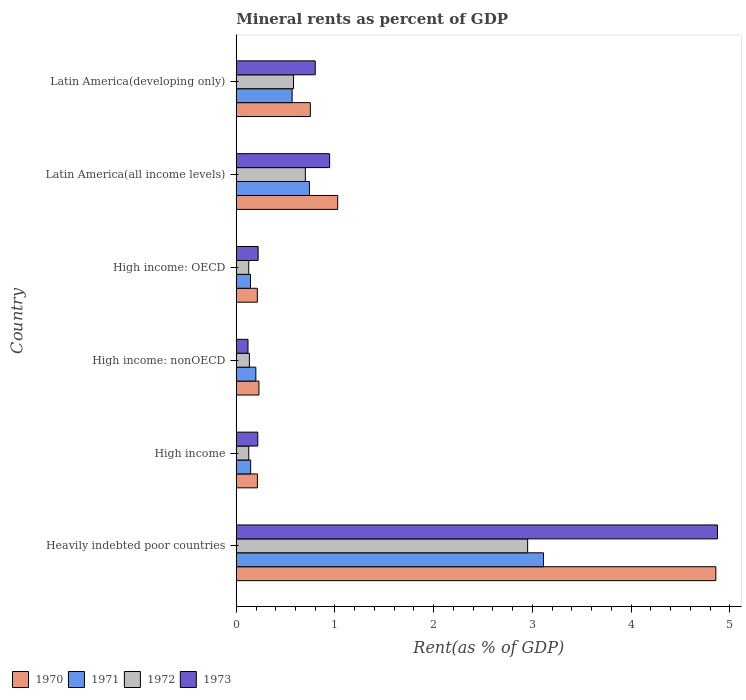How many different coloured bars are there?
Your response must be concise. 4. How many groups of bars are there?
Offer a very short reply. 6. Are the number of bars per tick equal to the number of legend labels?
Keep it short and to the point. Yes. What is the label of the 1st group of bars from the top?
Ensure brevity in your answer.  Latin America(developing only). In how many cases, is the number of bars for a given country not equal to the number of legend labels?
Offer a terse response. 0. What is the mineral rent in 1971 in High income: nonOECD?
Make the answer very short. 0.2. Across all countries, what is the maximum mineral rent in 1970?
Make the answer very short. 4.86. Across all countries, what is the minimum mineral rent in 1970?
Provide a succinct answer. 0.21. In which country was the mineral rent in 1972 maximum?
Your response must be concise. Heavily indebted poor countries. In which country was the mineral rent in 1972 minimum?
Keep it short and to the point. High income: OECD. What is the total mineral rent in 1971 in the graph?
Offer a very short reply. 4.91. What is the difference between the mineral rent in 1970 in High income and that in High income: nonOECD?
Provide a short and direct response. -0.02. What is the difference between the mineral rent in 1972 in Heavily indebted poor countries and the mineral rent in 1970 in High income?
Provide a succinct answer. 2.74. What is the average mineral rent in 1973 per country?
Keep it short and to the point. 1.2. What is the difference between the mineral rent in 1971 and mineral rent in 1973 in Latin America(developing only)?
Provide a succinct answer. -0.23. What is the ratio of the mineral rent in 1972 in Heavily indebted poor countries to that in High income?
Your answer should be compact. 23.3. Is the mineral rent in 1972 in High income less than that in Latin America(all income levels)?
Your response must be concise. Yes. Is the difference between the mineral rent in 1971 in High income and Latin America(developing only) greater than the difference between the mineral rent in 1973 in High income and Latin America(developing only)?
Give a very brief answer. Yes. What is the difference between the highest and the second highest mineral rent in 1972?
Provide a short and direct response. 2.25. What is the difference between the highest and the lowest mineral rent in 1970?
Ensure brevity in your answer.  4.64. In how many countries, is the mineral rent in 1970 greater than the average mineral rent in 1970 taken over all countries?
Provide a succinct answer. 1. Is the sum of the mineral rent in 1970 in Heavily indebted poor countries and Latin America(developing only) greater than the maximum mineral rent in 1973 across all countries?
Ensure brevity in your answer.  Yes. What does the 3rd bar from the top in Latin America(all income levels) represents?
Make the answer very short. 1971. What does the 1st bar from the bottom in High income: OECD represents?
Your answer should be very brief. 1970. How many bars are there?
Ensure brevity in your answer.  24. How many countries are there in the graph?
Provide a short and direct response. 6. What is the difference between two consecutive major ticks on the X-axis?
Your response must be concise. 1. Does the graph contain any zero values?
Ensure brevity in your answer.  No. Does the graph contain grids?
Ensure brevity in your answer.  No. How are the legend labels stacked?
Offer a very short reply. Horizontal. What is the title of the graph?
Give a very brief answer. Mineral rents as percent of GDP. Does "1960" appear as one of the legend labels in the graph?
Your answer should be very brief. No. What is the label or title of the X-axis?
Your answer should be compact. Rent(as % of GDP). What is the Rent(as % of GDP) in 1970 in Heavily indebted poor countries?
Your answer should be compact. 4.86. What is the Rent(as % of GDP) of 1971 in Heavily indebted poor countries?
Keep it short and to the point. 3.11. What is the Rent(as % of GDP) of 1972 in Heavily indebted poor countries?
Provide a succinct answer. 2.95. What is the Rent(as % of GDP) of 1973 in Heavily indebted poor countries?
Provide a short and direct response. 4.87. What is the Rent(as % of GDP) in 1970 in High income?
Keep it short and to the point. 0.21. What is the Rent(as % of GDP) of 1971 in High income?
Offer a very short reply. 0.15. What is the Rent(as % of GDP) of 1972 in High income?
Give a very brief answer. 0.13. What is the Rent(as % of GDP) in 1973 in High income?
Offer a very short reply. 0.22. What is the Rent(as % of GDP) in 1970 in High income: nonOECD?
Your response must be concise. 0.23. What is the Rent(as % of GDP) of 1971 in High income: nonOECD?
Give a very brief answer. 0.2. What is the Rent(as % of GDP) of 1972 in High income: nonOECD?
Keep it short and to the point. 0.13. What is the Rent(as % of GDP) in 1973 in High income: nonOECD?
Your response must be concise. 0.12. What is the Rent(as % of GDP) of 1970 in High income: OECD?
Ensure brevity in your answer.  0.21. What is the Rent(as % of GDP) in 1971 in High income: OECD?
Offer a very short reply. 0.14. What is the Rent(as % of GDP) of 1972 in High income: OECD?
Provide a short and direct response. 0.13. What is the Rent(as % of GDP) in 1973 in High income: OECD?
Ensure brevity in your answer.  0.22. What is the Rent(as % of GDP) in 1970 in Latin America(all income levels)?
Give a very brief answer. 1.03. What is the Rent(as % of GDP) of 1971 in Latin America(all income levels)?
Ensure brevity in your answer.  0.74. What is the Rent(as % of GDP) in 1972 in Latin America(all income levels)?
Provide a succinct answer. 0.7. What is the Rent(as % of GDP) in 1973 in Latin America(all income levels)?
Your answer should be compact. 0.95. What is the Rent(as % of GDP) of 1970 in Latin America(developing only)?
Ensure brevity in your answer.  0.75. What is the Rent(as % of GDP) in 1971 in Latin America(developing only)?
Offer a terse response. 0.57. What is the Rent(as % of GDP) of 1972 in Latin America(developing only)?
Provide a succinct answer. 0.58. What is the Rent(as % of GDP) in 1973 in Latin America(developing only)?
Offer a terse response. 0.8. Across all countries, what is the maximum Rent(as % of GDP) in 1970?
Offer a very short reply. 4.86. Across all countries, what is the maximum Rent(as % of GDP) of 1971?
Keep it short and to the point. 3.11. Across all countries, what is the maximum Rent(as % of GDP) in 1972?
Your response must be concise. 2.95. Across all countries, what is the maximum Rent(as % of GDP) in 1973?
Ensure brevity in your answer.  4.87. Across all countries, what is the minimum Rent(as % of GDP) of 1970?
Offer a very short reply. 0.21. Across all countries, what is the minimum Rent(as % of GDP) of 1971?
Provide a short and direct response. 0.14. Across all countries, what is the minimum Rent(as % of GDP) in 1972?
Give a very brief answer. 0.13. Across all countries, what is the minimum Rent(as % of GDP) in 1973?
Your answer should be very brief. 0.12. What is the total Rent(as % of GDP) in 1970 in the graph?
Your response must be concise. 7.29. What is the total Rent(as % of GDP) of 1971 in the graph?
Provide a short and direct response. 4.91. What is the total Rent(as % of GDP) of 1972 in the graph?
Your answer should be compact. 4.62. What is the total Rent(as % of GDP) of 1973 in the graph?
Provide a short and direct response. 7.18. What is the difference between the Rent(as % of GDP) in 1970 in Heavily indebted poor countries and that in High income?
Keep it short and to the point. 4.64. What is the difference between the Rent(as % of GDP) of 1971 in Heavily indebted poor countries and that in High income?
Ensure brevity in your answer.  2.97. What is the difference between the Rent(as % of GDP) in 1972 in Heavily indebted poor countries and that in High income?
Keep it short and to the point. 2.82. What is the difference between the Rent(as % of GDP) of 1973 in Heavily indebted poor countries and that in High income?
Provide a succinct answer. 4.66. What is the difference between the Rent(as % of GDP) in 1970 in Heavily indebted poor countries and that in High income: nonOECD?
Your response must be concise. 4.63. What is the difference between the Rent(as % of GDP) in 1971 in Heavily indebted poor countries and that in High income: nonOECD?
Provide a succinct answer. 2.91. What is the difference between the Rent(as % of GDP) in 1972 in Heavily indebted poor countries and that in High income: nonOECD?
Your response must be concise. 2.82. What is the difference between the Rent(as % of GDP) in 1973 in Heavily indebted poor countries and that in High income: nonOECD?
Offer a very short reply. 4.75. What is the difference between the Rent(as % of GDP) in 1970 in Heavily indebted poor countries and that in High income: OECD?
Your answer should be very brief. 4.64. What is the difference between the Rent(as % of GDP) in 1971 in Heavily indebted poor countries and that in High income: OECD?
Your answer should be compact. 2.97. What is the difference between the Rent(as % of GDP) in 1972 in Heavily indebted poor countries and that in High income: OECD?
Give a very brief answer. 2.83. What is the difference between the Rent(as % of GDP) in 1973 in Heavily indebted poor countries and that in High income: OECD?
Your answer should be compact. 4.65. What is the difference between the Rent(as % of GDP) in 1970 in Heavily indebted poor countries and that in Latin America(all income levels)?
Your response must be concise. 3.83. What is the difference between the Rent(as % of GDP) in 1971 in Heavily indebted poor countries and that in Latin America(all income levels)?
Your response must be concise. 2.37. What is the difference between the Rent(as % of GDP) of 1972 in Heavily indebted poor countries and that in Latin America(all income levels)?
Your response must be concise. 2.25. What is the difference between the Rent(as % of GDP) of 1973 in Heavily indebted poor countries and that in Latin America(all income levels)?
Provide a short and direct response. 3.93. What is the difference between the Rent(as % of GDP) in 1970 in Heavily indebted poor countries and that in Latin America(developing only)?
Ensure brevity in your answer.  4.11. What is the difference between the Rent(as % of GDP) of 1971 in Heavily indebted poor countries and that in Latin America(developing only)?
Your answer should be very brief. 2.55. What is the difference between the Rent(as % of GDP) in 1972 in Heavily indebted poor countries and that in Latin America(developing only)?
Ensure brevity in your answer.  2.37. What is the difference between the Rent(as % of GDP) in 1973 in Heavily indebted poor countries and that in Latin America(developing only)?
Offer a very short reply. 4.07. What is the difference between the Rent(as % of GDP) in 1970 in High income and that in High income: nonOECD?
Ensure brevity in your answer.  -0.02. What is the difference between the Rent(as % of GDP) of 1971 in High income and that in High income: nonOECD?
Make the answer very short. -0.05. What is the difference between the Rent(as % of GDP) in 1972 in High income and that in High income: nonOECD?
Ensure brevity in your answer.  -0.01. What is the difference between the Rent(as % of GDP) in 1973 in High income and that in High income: nonOECD?
Make the answer very short. 0.1. What is the difference between the Rent(as % of GDP) of 1970 in High income and that in High income: OECD?
Your answer should be compact. 0. What is the difference between the Rent(as % of GDP) of 1971 in High income and that in High income: OECD?
Give a very brief answer. 0. What is the difference between the Rent(as % of GDP) of 1972 in High income and that in High income: OECD?
Your answer should be compact. 0. What is the difference between the Rent(as % of GDP) of 1973 in High income and that in High income: OECD?
Ensure brevity in your answer.  -0. What is the difference between the Rent(as % of GDP) of 1970 in High income and that in Latin America(all income levels)?
Your answer should be compact. -0.81. What is the difference between the Rent(as % of GDP) of 1971 in High income and that in Latin America(all income levels)?
Your answer should be very brief. -0.6. What is the difference between the Rent(as % of GDP) of 1972 in High income and that in Latin America(all income levels)?
Your response must be concise. -0.57. What is the difference between the Rent(as % of GDP) of 1973 in High income and that in Latin America(all income levels)?
Make the answer very short. -0.73. What is the difference between the Rent(as % of GDP) of 1970 in High income and that in Latin America(developing only)?
Keep it short and to the point. -0.54. What is the difference between the Rent(as % of GDP) in 1971 in High income and that in Latin America(developing only)?
Provide a short and direct response. -0.42. What is the difference between the Rent(as % of GDP) of 1972 in High income and that in Latin America(developing only)?
Your response must be concise. -0.45. What is the difference between the Rent(as % of GDP) of 1973 in High income and that in Latin America(developing only)?
Offer a terse response. -0.58. What is the difference between the Rent(as % of GDP) in 1970 in High income: nonOECD and that in High income: OECD?
Your answer should be compact. 0.02. What is the difference between the Rent(as % of GDP) of 1971 in High income: nonOECD and that in High income: OECD?
Give a very brief answer. 0.05. What is the difference between the Rent(as % of GDP) of 1972 in High income: nonOECD and that in High income: OECD?
Your response must be concise. 0.01. What is the difference between the Rent(as % of GDP) in 1973 in High income: nonOECD and that in High income: OECD?
Offer a very short reply. -0.1. What is the difference between the Rent(as % of GDP) in 1970 in High income: nonOECD and that in Latin America(all income levels)?
Your answer should be compact. -0.8. What is the difference between the Rent(as % of GDP) in 1971 in High income: nonOECD and that in Latin America(all income levels)?
Your answer should be compact. -0.54. What is the difference between the Rent(as % of GDP) of 1972 in High income: nonOECD and that in Latin America(all income levels)?
Keep it short and to the point. -0.57. What is the difference between the Rent(as % of GDP) in 1973 in High income: nonOECD and that in Latin America(all income levels)?
Make the answer very short. -0.83. What is the difference between the Rent(as % of GDP) in 1970 in High income: nonOECD and that in Latin America(developing only)?
Ensure brevity in your answer.  -0.52. What is the difference between the Rent(as % of GDP) in 1971 in High income: nonOECD and that in Latin America(developing only)?
Provide a succinct answer. -0.37. What is the difference between the Rent(as % of GDP) of 1972 in High income: nonOECD and that in Latin America(developing only)?
Offer a terse response. -0.45. What is the difference between the Rent(as % of GDP) of 1973 in High income: nonOECD and that in Latin America(developing only)?
Your answer should be compact. -0.68. What is the difference between the Rent(as % of GDP) of 1970 in High income: OECD and that in Latin America(all income levels)?
Keep it short and to the point. -0.81. What is the difference between the Rent(as % of GDP) in 1971 in High income: OECD and that in Latin America(all income levels)?
Your answer should be compact. -0.6. What is the difference between the Rent(as % of GDP) in 1972 in High income: OECD and that in Latin America(all income levels)?
Keep it short and to the point. -0.57. What is the difference between the Rent(as % of GDP) in 1973 in High income: OECD and that in Latin America(all income levels)?
Your answer should be very brief. -0.72. What is the difference between the Rent(as % of GDP) in 1970 in High income: OECD and that in Latin America(developing only)?
Your response must be concise. -0.54. What is the difference between the Rent(as % of GDP) of 1971 in High income: OECD and that in Latin America(developing only)?
Your answer should be very brief. -0.42. What is the difference between the Rent(as % of GDP) of 1972 in High income: OECD and that in Latin America(developing only)?
Provide a succinct answer. -0.45. What is the difference between the Rent(as % of GDP) of 1973 in High income: OECD and that in Latin America(developing only)?
Offer a terse response. -0.58. What is the difference between the Rent(as % of GDP) in 1970 in Latin America(all income levels) and that in Latin America(developing only)?
Ensure brevity in your answer.  0.28. What is the difference between the Rent(as % of GDP) of 1971 in Latin America(all income levels) and that in Latin America(developing only)?
Offer a very short reply. 0.18. What is the difference between the Rent(as % of GDP) in 1972 in Latin America(all income levels) and that in Latin America(developing only)?
Keep it short and to the point. 0.12. What is the difference between the Rent(as % of GDP) in 1973 in Latin America(all income levels) and that in Latin America(developing only)?
Provide a succinct answer. 0.15. What is the difference between the Rent(as % of GDP) in 1970 in Heavily indebted poor countries and the Rent(as % of GDP) in 1971 in High income?
Provide a succinct answer. 4.71. What is the difference between the Rent(as % of GDP) in 1970 in Heavily indebted poor countries and the Rent(as % of GDP) in 1972 in High income?
Your answer should be compact. 4.73. What is the difference between the Rent(as % of GDP) in 1970 in Heavily indebted poor countries and the Rent(as % of GDP) in 1973 in High income?
Ensure brevity in your answer.  4.64. What is the difference between the Rent(as % of GDP) of 1971 in Heavily indebted poor countries and the Rent(as % of GDP) of 1972 in High income?
Your response must be concise. 2.99. What is the difference between the Rent(as % of GDP) in 1971 in Heavily indebted poor countries and the Rent(as % of GDP) in 1973 in High income?
Your answer should be compact. 2.89. What is the difference between the Rent(as % of GDP) of 1972 in Heavily indebted poor countries and the Rent(as % of GDP) of 1973 in High income?
Provide a succinct answer. 2.73. What is the difference between the Rent(as % of GDP) of 1970 in Heavily indebted poor countries and the Rent(as % of GDP) of 1971 in High income: nonOECD?
Provide a succinct answer. 4.66. What is the difference between the Rent(as % of GDP) of 1970 in Heavily indebted poor countries and the Rent(as % of GDP) of 1972 in High income: nonOECD?
Offer a very short reply. 4.72. What is the difference between the Rent(as % of GDP) in 1970 in Heavily indebted poor countries and the Rent(as % of GDP) in 1973 in High income: nonOECD?
Ensure brevity in your answer.  4.74. What is the difference between the Rent(as % of GDP) of 1971 in Heavily indebted poor countries and the Rent(as % of GDP) of 1972 in High income: nonOECD?
Ensure brevity in your answer.  2.98. What is the difference between the Rent(as % of GDP) of 1971 in Heavily indebted poor countries and the Rent(as % of GDP) of 1973 in High income: nonOECD?
Ensure brevity in your answer.  2.99. What is the difference between the Rent(as % of GDP) in 1972 in Heavily indebted poor countries and the Rent(as % of GDP) in 1973 in High income: nonOECD?
Your answer should be compact. 2.83. What is the difference between the Rent(as % of GDP) of 1970 in Heavily indebted poor countries and the Rent(as % of GDP) of 1971 in High income: OECD?
Give a very brief answer. 4.71. What is the difference between the Rent(as % of GDP) of 1970 in Heavily indebted poor countries and the Rent(as % of GDP) of 1972 in High income: OECD?
Keep it short and to the point. 4.73. What is the difference between the Rent(as % of GDP) of 1970 in Heavily indebted poor countries and the Rent(as % of GDP) of 1973 in High income: OECD?
Your answer should be very brief. 4.64. What is the difference between the Rent(as % of GDP) in 1971 in Heavily indebted poor countries and the Rent(as % of GDP) in 1972 in High income: OECD?
Make the answer very short. 2.99. What is the difference between the Rent(as % of GDP) of 1971 in Heavily indebted poor countries and the Rent(as % of GDP) of 1973 in High income: OECD?
Ensure brevity in your answer.  2.89. What is the difference between the Rent(as % of GDP) in 1972 in Heavily indebted poor countries and the Rent(as % of GDP) in 1973 in High income: OECD?
Your answer should be compact. 2.73. What is the difference between the Rent(as % of GDP) in 1970 in Heavily indebted poor countries and the Rent(as % of GDP) in 1971 in Latin America(all income levels)?
Your response must be concise. 4.12. What is the difference between the Rent(as % of GDP) of 1970 in Heavily indebted poor countries and the Rent(as % of GDP) of 1972 in Latin America(all income levels)?
Provide a succinct answer. 4.16. What is the difference between the Rent(as % of GDP) of 1970 in Heavily indebted poor countries and the Rent(as % of GDP) of 1973 in Latin America(all income levels)?
Provide a succinct answer. 3.91. What is the difference between the Rent(as % of GDP) of 1971 in Heavily indebted poor countries and the Rent(as % of GDP) of 1972 in Latin America(all income levels)?
Offer a very short reply. 2.41. What is the difference between the Rent(as % of GDP) of 1971 in Heavily indebted poor countries and the Rent(as % of GDP) of 1973 in Latin America(all income levels)?
Provide a short and direct response. 2.17. What is the difference between the Rent(as % of GDP) of 1972 in Heavily indebted poor countries and the Rent(as % of GDP) of 1973 in Latin America(all income levels)?
Offer a terse response. 2.01. What is the difference between the Rent(as % of GDP) of 1970 in Heavily indebted poor countries and the Rent(as % of GDP) of 1971 in Latin America(developing only)?
Your response must be concise. 4.29. What is the difference between the Rent(as % of GDP) in 1970 in Heavily indebted poor countries and the Rent(as % of GDP) in 1972 in Latin America(developing only)?
Keep it short and to the point. 4.28. What is the difference between the Rent(as % of GDP) of 1970 in Heavily indebted poor countries and the Rent(as % of GDP) of 1973 in Latin America(developing only)?
Offer a terse response. 4.06. What is the difference between the Rent(as % of GDP) in 1971 in Heavily indebted poor countries and the Rent(as % of GDP) in 1972 in Latin America(developing only)?
Offer a very short reply. 2.53. What is the difference between the Rent(as % of GDP) in 1971 in Heavily indebted poor countries and the Rent(as % of GDP) in 1973 in Latin America(developing only)?
Keep it short and to the point. 2.31. What is the difference between the Rent(as % of GDP) in 1972 in Heavily indebted poor countries and the Rent(as % of GDP) in 1973 in Latin America(developing only)?
Keep it short and to the point. 2.15. What is the difference between the Rent(as % of GDP) of 1970 in High income and the Rent(as % of GDP) of 1971 in High income: nonOECD?
Your response must be concise. 0.02. What is the difference between the Rent(as % of GDP) in 1970 in High income and the Rent(as % of GDP) in 1972 in High income: nonOECD?
Your answer should be compact. 0.08. What is the difference between the Rent(as % of GDP) of 1970 in High income and the Rent(as % of GDP) of 1973 in High income: nonOECD?
Your response must be concise. 0.1. What is the difference between the Rent(as % of GDP) in 1971 in High income and the Rent(as % of GDP) in 1972 in High income: nonOECD?
Ensure brevity in your answer.  0.01. What is the difference between the Rent(as % of GDP) in 1971 in High income and the Rent(as % of GDP) in 1973 in High income: nonOECD?
Give a very brief answer. 0.03. What is the difference between the Rent(as % of GDP) of 1972 in High income and the Rent(as % of GDP) of 1973 in High income: nonOECD?
Your answer should be compact. 0.01. What is the difference between the Rent(as % of GDP) in 1970 in High income and the Rent(as % of GDP) in 1971 in High income: OECD?
Your answer should be compact. 0.07. What is the difference between the Rent(as % of GDP) in 1970 in High income and the Rent(as % of GDP) in 1972 in High income: OECD?
Your response must be concise. 0.09. What is the difference between the Rent(as % of GDP) of 1970 in High income and the Rent(as % of GDP) of 1973 in High income: OECD?
Offer a very short reply. -0.01. What is the difference between the Rent(as % of GDP) in 1971 in High income and the Rent(as % of GDP) in 1972 in High income: OECD?
Ensure brevity in your answer.  0.02. What is the difference between the Rent(as % of GDP) in 1971 in High income and the Rent(as % of GDP) in 1973 in High income: OECD?
Provide a short and direct response. -0.08. What is the difference between the Rent(as % of GDP) of 1972 in High income and the Rent(as % of GDP) of 1973 in High income: OECD?
Your response must be concise. -0.1. What is the difference between the Rent(as % of GDP) of 1970 in High income and the Rent(as % of GDP) of 1971 in Latin America(all income levels)?
Provide a succinct answer. -0.53. What is the difference between the Rent(as % of GDP) in 1970 in High income and the Rent(as % of GDP) in 1972 in Latin America(all income levels)?
Keep it short and to the point. -0.49. What is the difference between the Rent(as % of GDP) in 1970 in High income and the Rent(as % of GDP) in 1973 in Latin America(all income levels)?
Keep it short and to the point. -0.73. What is the difference between the Rent(as % of GDP) in 1971 in High income and the Rent(as % of GDP) in 1972 in Latin America(all income levels)?
Keep it short and to the point. -0.55. What is the difference between the Rent(as % of GDP) of 1971 in High income and the Rent(as % of GDP) of 1973 in Latin America(all income levels)?
Provide a short and direct response. -0.8. What is the difference between the Rent(as % of GDP) of 1972 in High income and the Rent(as % of GDP) of 1973 in Latin America(all income levels)?
Keep it short and to the point. -0.82. What is the difference between the Rent(as % of GDP) of 1970 in High income and the Rent(as % of GDP) of 1971 in Latin America(developing only)?
Make the answer very short. -0.35. What is the difference between the Rent(as % of GDP) of 1970 in High income and the Rent(as % of GDP) of 1972 in Latin America(developing only)?
Provide a succinct answer. -0.37. What is the difference between the Rent(as % of GDP) of 1970 in High income and the Rent(as % of GDP) of 1973 in Latin America(developing only)?
Offer a terse response. -0.59. What is the difference between the Rent(as % of GDP) in 1971 in High income and the Rent(as % of GDP) in 1972 in Latin America(developing only)?
Your response must be concise. -0.43. What is the difference between the Rent(as % of GDP) of 1971 in High income and the Rent(as % of GDP) of 1973 in Latin America(developing only)?
Give a very brief answer. -0.65. What is the difference between the Rent(as % of GDP) of 1972 in High income and the Rent(as % of GDP) of 1973 in Latin America(developing only)?
Your answer should be very brief. -0.67. What is the difference between the Rent(as % of GDP) in 1970 in High income: nonOECD and the Rent(as % of GDP) in 1971 in High income: OECD?
Provide a short and direct response. 0.09. What is the difference between the Rent(as % of GDP) in 1970 in High income: nonOECD and the Rent(as % of GDP) in 1972 in High income: OECD?
Make the answer very short. 0.1. What is the difference between the Rent(as % of GDP) in 1970 in High income: nonOECD and the Rent(as % of GDP) in 1973 in High income: OECD?
Make the answer very short. 0.01. What is the difference between the Rent(as % of GDP) in 1971 in High income: nonOECD and the Rent(as % of GDP) in 1972 in High income: OECD?
Provide a succinct answer. 0.07. What is the difference between the Rent(as % of GDP) of 1971 in High income: nonOECD and the Rent(as % of GDP) of 1973 in High income: OECD?
Provide a short and direct response. -0.02. What is the difference between the Rent(as % of GDP) in 1972 in High income: nonOECD and the Rent(as % of GDP) in 1973 in High income: OECD?
Give a very brief answer. -0.09. What is the difference between the Rent(as % of GDP) of 1970 in High income: nonOECD and the Rent(as % of GDP) of 1971 in Latin America(all income levels)?
Your answer should be very brief. -0.51. What is the difference between the Rent(as % of GDP) in 1970 in High income: nonOECD and the Rent(as % of GDP) in 1972 in Latin America(all income levels)?
Provide a short and direct response. -0.47. What is the difference between the Rent(as % of GDP) in 1970 in High income: nonOECD and the Rent(as % of GDP) in 1973 in Latin America(all income levels)?
Provide a succinct answer. -0.72. What is the difference between the Rent(as % of GDP) of 1971 in High income: nonOECD and the Rent(as % of GDP) of 1972 in Latin America(all income levels)?
Make the answer very short. -0.5. What is the difference between the Rent(as % of GDP) of 1971 in High income: nonOECD and the Rent(as % of GDP) of 1973 in Latin America(all income levels)?
Make the answer very short. -0.75. What is the difference between the Rent(as % of GDP) of 1972 in High income: nonOECD and the Rent(as % of GDP) of 1973 in Latin America(all income levels)?
Give a very brief answer. -0.81. What is the difference between the Rent(as % of GDP) in 1970 in High income: nonOECD and the Rent(as % of GDP) in 1971 in Latin America(developing only)?
Offer a very short reply. -0.34. What is the difference between the Rent(as % of GDP) in 1970 in High income: nonOECD and the Rent(as % of GDP) in 1972 in Latin America(developing only)?
Give a very brief answer. -0.35. What is the difference between the Rent(as % of GDP) in 1970 in High income: nonOECD and the Rent(as % of GDP) in 1973 in Latin America(developing only)?
Keep it short and to the point. -0.57. What is the difference between the Rent(as % of GDP) of 1971 in High income: nonOECD and the Rent(as % of GDP) of 1972 in Latin America(developing only)?
Ensure brevity in your answer.  -0.38. What is the difference between the Rent(as % of GDP) of 1971 in High income: nonOECD and the Rent(as % of GDP) of 1973 in Latin America(developing only)?
Offer a very short reply. -0.6. What is the difference between the Rent(as % of GDP) of 1972 in High income: nonOECD and the Rent(as % of GDP) of 1973 in Latin America(developing only)?
Give a very brief answer. -0.67. What is the difference between the Rent(as % of GDP) in 1970 in High income: OECD and the Rent(as % of GDP) in 1971 in Latin America(all income levels)?
Give a very brief answer. -0.53. What is the difference between the Rent(as % of GDP) of 1970 in High income: OECD and the Rent(as % of GDP) of 1972 in Latin America(all income levels)?
Your response must be concise. -0.49. What is the difference between the Rent(as % of GDP) of 1970 in High income: OECD and the Rent(as % of GDP) of 1973 in Latin America(all income levels)?
Your answer should be very brief. -0.73. What is the difference between the Rent(as % of GDP) of 1971 in High income: OECD and the Rent(as % of GDP) of 1972 in Latin America(all income levels)?
Provide a short and direct response. -0.56. What is the difference between the Rent(as % of GDP) of 1971 in High income: OECD and the Rent(as % of GDP) of 1973 in Latin America(all income levels)?
Offer a terse response. -0.8. What is the difference between the Rent(as % of GDP) in 1972 in High income: OECD and the Rent(as % of GDP) in 1973 in Latin America(all income levels)?
Provide a succinct answer. -0.82. What is the difference between the Rent(as % of GDP) in 1970 in High income: OECD and the Rent(as % of GDP) in 1971 in Latin America(developing only)?
Provide a short and direct response. -0.35. What is the difference between the Rent(as % of GDP) in 1970 in High income: OECD and the Rent(as % of GDP) in 1972 in Latin America(developing only)?
Ensure brevity in your answer.  -0.37. What is the difference between the Rent(as % of GDP) of 1970 in High income: OECD and the Rent(as % of GDP) of 1973 in Latin America(developing only)?
Ensure brevity in your answer.  -0.59. What is the difference between the Rent(as % of GDP) of 1971 in High income: OECD and the Rent(as % of GDP) of 1972 in Latin America(developing only)?
Provide a short and direct response. -0.44. What is the difference between the Rent(as % of GDP) of 1971 in High income: OECD and the Rent(as % of GDP) of 1973 in Latin America(developing only)?
Ensure brevity in your answer.  -0.66. What is the difference between the Rent(as % of GDP) in 1972 in High income: OECD and the Rent(as % of GDP) in 1973 in Latin America(developing only)?
Your response must be concise. -0.67. What is the difference between the Rent(as % of GDP) in 1970 in Latin America(all income levels) and the Rent(as % of GDP) in 1971 in Latin America(developing only)?
Give a very brief answer. 0.46. What is the difference between the Rent(as % of GDP) of 1970 in Latin America(all income levels) and the Rent(as % of GDP) of 1972 in Latin America(developing only)?
Provide a short and direct response. 0.45. What is the difference between the Rent(as % of GDP) in 1970 in Latin America(all income levels) and the Rent(as % of GDP) in 1973 in Latin America(developing only)?
Provide a succinct answer. 0.23. What is the difference between the Rent(as % of GDP) in 1971 in Latin America(all income levels) and the Rent(as % of GDP) in 1972 in Latin America(developing only)?
Offer a terse response. 0.16. What is the difference between the Rent(as % of GDP) in 1971 in Latin America(all income levels) and the Rent(as % of GDP) in 1973 in Latin America(developing only)?
Provide a succinct answer. -0.06. What is the difference between the Rent(as % of GDP) of 1972 in Latin America(all income levels) and the Rent(as % of GDP) of 1973 in Latin America(developing only)?
Give a very brief answer. -0.1. What is the average Rent(as % of GDP) in 1970 per country?
Provide a short and direct response. 1.22. What is the average Rent(as % of GDP) of 1971 per country?
Offer a terse response. 0.82. What is the average Rent(as % of GDP) in 1972 per country?
Make the answer very short. 0.77. What is the average Rent(as % of GDP) in 1973 per country?
Ensure brevity in your answer.  1.2. What is the difference between the Rent(as % of GDP) in 1970 and Rent(as % of GDP) in 1971 in Heavily indebted poor countries?
Keep it short and to the point. 1.75. What is the difference between the Rent(as % of GDP) of 1970 and Rent(as % of GDP) of 1972 in Heavily indebted poor countries?
Ensure brevity in your answer.  1.91. What is the difference between the Rent(as % of GDP) of 1970 and Rent(as % of GDP) of 1973 in Heavily indebted poor countries?
Your answer should be compact. -0.02. What is the difference between the Rent(as % of GDP) in 1971 and Rent(as % of GDP) in 1972 in Heavily indebted poor countries?
Offer a terse response. 0.16. What is the difference between the Rent(as % of GDP) of 1971 and Rent(as % of GDP) of 1973 in Heavily indebted poor countries?
Ensure brevity in your answer.  -1.76. What is the difference between the Rent(as % of GDP) of 1972 and Rent(as % of GDP) of 1973 in Heavily indebted poor countries?
Your answer should be compact. -1.92. What is the difference between the Rent(as % of GDP) in 1970 and Rent(as % of GDP) in 1971 in High income?
Make the answer very short. 0.07. What is the difference between the Rent(as % of GDP) in 1970 and Rent(as % of GDP) in 1972 in High income?
Provide a succinct answer. 0.09. What is the difference between the Rent(as % of GDP) in 1970 and Rent(as % of GDP) in 1973 in High income?
Offer a terse response. -0. What is the difference between the Rent(as % of GDP) of 1971 and Rent(as % of GDP) of 1972 in High income?
Your answer should be compact. 0.02. What is the difference between the Rent(as % of GDP) of 1971 and Rent(as % of GDP) of 1973 in High income?
Your answer should be compact. -0.07. What is the difference between the Rent(as % of GDP) of 1972 and Rent(as % of GDP) of 1973 in High income?
Provide a succinct answer. -0.09. What is the difference between the Rent(as % of GDP) in 1970 and Rent(as % of GDP) in 1971 in High income: nonOECD?
Your response must be concise. 0.03. What is the difference between the Rent(as % of GDP) of 1970 and Rent(as % of GDP) of 1972 in High income: nonOECD?
Your answer should be very brief. 0.1. What is the difference between the Rent(as % of GDP) of 1970 and Rent(as % of GDP) of 1973 in High income: nonOECD?
Provide a short and direct response. 0.11. What is the difference between the Rent(as % of GDP) in 1971 and Rent(as % of GDP) in 1972 in High income: nonOECD?
Provide a succinct answer. 0.07. What is the difference between the Rent(as % of GDP) of 1971 and Rent(as % of GDP) of 1973 in High income: nonOECD?
Offer a terse response. 0.08. What is the difference between the Rent(as % of GDP) of 1972 and Rent(as % of GDP) of 1973 in High income: nonOECD?
Your answer should be compact. 0.01. What is the difference between the Rent(as % of GDP) of 1970 and Rent(as % of GDP) of 1971 in High income: OECD?
Keep it short and to the point. 0.07. What is the difference between the Rent(as % of GDP) of 1970 and Rent(as % of GDP) of 1972 in High income: OECD?
Make the answer very short. 0.09. What is the difference between the Rent(as % of GDP) of 1970 and Rent(as % of GDP) of 1973 in High income: OECD?
Offer a very short reply. -0.01. What is the difference between the Rent(as % of GDP) of 1971 and Rent(as % of GDP) of 1972 in High income: OECD?
Provide a short and direct response. 0.02. What is the difference between the Rent(as % of GDP) in 1971 and Rent(as % of GDP) in 1973 in High income: OECD?
Offer a terse response. -0.08. What is the difference between the Rent(as % of GDP) in 1972 and Rent(as % of GDP) in 1973 in High income: OECD?
Provide a short and direct response. -0.1. What is the difference between the Rent(as % of GDP) of 1970 and Rent(as % of GDP) of 1971 in Latin America(all income levels)?
Give a very brief answer. 0.29. What is the difference between the Rent(as % of GDP) in 1970 and Rent(as % of GDP) in 1972 in Latin America(all income levels)?
Your answer should be very brief. 0.33. What is the difference between the Rent(as % of GDP) in 1970 and Rent(as % of GDP) in 1973 in Latin America(all income levels)?
Keep it short and to the point. 0.08. What is the difference between the Rent(as % of GDP) of 1971 and Rent(as % of GDP) of 1972 in Latin America(all income levels)?
Provide a succinct answer. 0.04. What is the difference between the Rent(as % of GDP) in 1971 and Rent(as % of GDP) in 1973 in Latin America(all income levels)?
Your response must be concise. -0.2. What is the difference between the Rent(as % of GDP) of 1972 and Rent(as % of GDP) of 1973 in Latin America(all income levels)?
Offer a terse response. -0.25. What is the difference between the Rent(as % of GDP) of 1970 and Rent(as % of GDP) of 1971 in Latin America(developing only)?
Offer a terse response. 0.18. What is the difference between the Rent(as % of GDP) of 1970 and Rent(as % of GDP) of 1972 in Latin America(developing only)?
Keep it short and to the point. 0.17. What is the difference between the Rent(as % of GDP) in 1970 and Rent(as % of GDP) in 1973 in Latin America(developing only)?
Your response must be concise. -0.05. What is the difference between the Rent(as % of GDP) of 1971 and Rent(as % of GDP) of 1972 in Latin America(developing only)?
Offer a terse response. -0.01. What is the difference between the Rent(as % of GDP) in 1971 and Rent(as % of GDP) in 1973 in Latin America(developing only)?
Ensure brevity in your answer.  -0.23. What is the difference between the Rent(as % of GDP) in 1972 and Rent(as % of GDP) in 1973 in Latin America(developing only)?
Give a very brief answer. -0.22. What is the ratio of the Rent(as % of GDP) of 1970 in Heavily indebted poor countries to that in High income?
Your answer should be compact. 22.69. What is the ratio of the Rent(as % of GDP) in 1971 in Heavily indebted poor countries to that in High income?
Your answer should be compact. 21.31. What is the ratio of the Rent(as % of GDP) of 1972 in Heavily indebted poor countries to that in High income?
Your response must be concise. 23.3. What is the ratio of the Rent(as % of GDP) of 1973 in Heavily indebted poor countries to that in High income?
Offer a terse response. 22.35. What is the ratio of the Rent(as % of GDP) of 1970 in Heavily indebted poor countries to that in High income: nonOECD?
Your answer should be very brief. 21.14. What is the ratio of the Rent(as % of GDP) in 1971 in Heavily indebted poor countries to that in High income: nonOECD?
Keep it short and to the point. 15.68. What is the ratio of the Rent(as % of GDP) of 1972 in Heavily indebted poor countries to that in High income: nonOECD?
Provide a short and direct response. 22.17. What is the ratio of the Rent(as % of GDP) in 1973 in Heavily indebted poor countries to that in High income: nonOECD?
Offer a very short reply. 40.95. What is the ratio of the Rent(as % of GDP) of 1970 in Heavily indebted poor countries to that in High income: OECD?
Provide a succinct answer. 22.74. What is the ratio of the Rent(as % of GDP) of 1971 in Heavily indebted poor countries to that in High income: OECD?
Make the answer very short. 21.57. What is the ratio of the Rent(as % of GDP) of 1972 in Heavily indebted poor countries to that in High income: OECD?
Provide a short and direct response. 23.34. What is the ratio of the Rent(as % of GDP) in 1973 in Heavily indebted poor countries to that in High income: OECD?
Provide a short and direct response. 21.98. What is the ratio of the Rent(as % of GDP) in 1970 in Heavily indebted poor countries to that in Latin America(all income levels)?
Provide a succinct answer. 4.73. What is the ratio of the Rent(as % of GDP) of 1971 in Heavily indebted poor countries to that in Latin America(all income levels)?
Your answer should be very brief. 4.2. What is the ratio of the Rent(as % of GDP) in 1972 in Heavily indebted poor countries to that in Latin America(all income levels)?
Your answer should be compact. 4.22. What is the ratio of the Rent(as % of GDP) in 1973 in Heavily indebted poor countries to that in Latin America(all income levels)?
Your answer should be very brief. 5.15. What is the ratio of the Rent(as % of GDP) of 1970 in Heavily indebted poor countries to that in Latin America(developing only)?
Provide a short and direct response. 6.47. What is the ratio of the Rent(as % of GDP) of 1971 in Heavily indebted poor countries to that in Latin America(developing only)?
Make the answer very short. 5.5. What is the ratio of the Rent(as % of GDP) in 1972 in Heavily indebted poor countries to that in Latin America(developing only)?
Your answer should be very brief. 5.09. What is the ratio of the Rent(as % of GDP) of 1973 in Heavily indebted poor countries to that in Latin America(developing only)?
Your response must be concise. 6.09. What is the ratio of the Rent(as % of GDP) in 1970 in High income to that in High income: nonOECD?
Give a very brief answer. 0.93. What is the ratio of the Rent(as % of GDP) in 1971 in High income to that in High income: nonOECD?
Give a very brief answer. 0.74. What is the ratio of the Rent(as % of GDP) in 1972 in High income to that in High income: nonOECD?
Give a very brief answer. 0.95. What is the ratio of the Rent(as % of GDP) of 1973 in High income to that in High income: nonOECD?
Provide a short and direct response. 1.83. What is the ratio of the Rent(as % of GDP) of 1970 in High income to that in High income: OECD?
Give a very brief answer. 1. What is the ratio of the Rent(as % of GDP) in 1971 in High income to that in High income: OECD?
Your response must be concise. 1.01. What is the ratio of the Rent(as % of GDP) of 1972 in High income to that in High income: OECD?
Offer a terse response. 1. What is the ratio of the Rent(as % of GDP) of 1973 in High income to that in High income: OECD?
Ensure brevity in your answer.  0.98. What is the ratio of the Rent(as % of GDP) of 1970 in High income to that in Latin America(all income levels)?
Your answer should be very brief. 0.21. What is the ratio of the Rent(as % of GDP) of 1971 in High income to that in Latin America(all income levels)?
Offer a very short reply. 0.2. What is the ratio of the Rent(as % of GDP) of 1972 in High income to that in Latin America(all income levels)?
Provide a succinct answer. 0.18. What is the ratio of the Rent(as % of GDP) in 1973 in High income to that in Latin America(all income levels)?
Offer a terse response. 0.23. What is the ratio of the Rent(as % of GDP) in 1970 in High income to that in Latin America(developing only)?
Keep it short and to the point. 0.29. What is the ratio of the Rent(as % of GDP) of 1971 in High income to that in Latin America(developing only)?
Give a very brief answer. 0.26. What is the ratio of the Rent(as % of GDP) in 1972 in High income to that in Latin America(developing only)?
Give a very brief answer. 0.22. What is the ratio of the Rent(as % of GDP) of 1973 in High income to that in Latin America(developing only)?
Make the answer very short. 0.27. What is the ratio of the Rent(as % of GDP) of 1970 in High income: nonOECD to that in High income: OECD?
Your answer should be very brief. 1.08. What is the ratio of the Rent(as % of GDP) of 1971 in High income: nonOECD to that in High income: OECD?
Keep it short and to the point. 1.38. What is the ratio of the Rent(as % of GDP) of 1972 in High income: nonOECD to that in High income: OECD?
Your answer should be very brief. 1.05. What is the ratio of the Rent(as % of GDP) of 1973 in High income: nonOECD to that in High income: OECD?
Provide a short and direct response. 0.54. What is the ratio of the Rent(as % of GDP) of 1970 in High income: nonOECD to that in Latin America(all income levels)?
Your response must be concise. 0.22. What is the ratio of the Rent(as % of GDP) in 1971 in High income: nonOECD to that in Latin America(all income levels)?
Your response must be concise. 0.27. What is the ratio of the Rent(as % of GDP) of 1972 in High income: nonOECD to that in Latin America(all income levels)?
Provide a short and direct response. 0.19. What is the ratio of the Rent(as % of GDP) of 1973 in High income: nonOECD to that in Latin America(all income levels)?
Offer a very short reply. 0.13. What is the ratio of the Rent(as % of GDP) of 1970 in High income: nonOECD to that in Latin America(developing only)?
Your answer should be very brief. 0.31. What is the ratio of the Rent(as % of GDP) in 1971 in High income: nonOECD to that in Latin America(developing only)?
Make the answer very short. 0.35. What is the ratio of the Rent(as % of GDP) in 1972 in High income: nonOECD to that in Latin America(developing only)?
Your answer should be very brief. 0.23. What is the ratio of the Rent(as % of GDP) in 1973 in High income: nonOECD to that in Latin America(developing only)?
Provide a short and direct response. 0.15. What is the ratio of the Rent(as % of GDP) in 1970 in High income: OECD to that in Latin America(all income levels)?
Provide a succinct answer. 0.21. What is the ratio of the Rent(as % of GDP) of 1971 in High income: OECD to that in Latin America(all income levels)?
Your answer should be very brief. 0.19. What is the ratio of the Rent(as % of GDP) of 1972 in High income: OECD to that in Latin America(all income levels)?
Give a very brief answer. 0.18. What is the ratio of the Rent(as % of GDP) in 1973 in High income: OECD to that in Latin America(all income levels)?
Your answer should be very brief. 0.23. What is the ratio of the Rent(as % of GDP) of 1970 in High income: OECD to that in Latin America(developing only)?
Your response must be concise. 0.28. What is the ratio of the Rent(as % of GDP) in 1971 in High income: OECD to that in Latin America(developing only)?
Your response must be concise. 0.26. What is the ratio of the Rent(as % of GDP) in 1972 in High income: OECD to that in Latin America(developing only)?
Offer a terse response. 0.22. What is the ratio of the Rent(as % of GDP) in 1973 in High income: OECD to that in Latin America(developing only)?
Your answer should be compact. 0.28. What is the ratio of the Rent(as % of GDP) of 1970 in Latin America(all income levels) to that in Latin America(developing only)?
Ensure brevity in your answer.  1.37. What is the ratio of the Rent(as % of GDP) of 1971 in Latin America(all income levels) to that in Latin America(developing only)?
Your response must be concise. 1.31. What is the ratio of the Rent(as % of GDP) in 1972 in Latin America(all income levels) to that in Latin America(developing only)?
Keep it short and to the point. 1.21. What is the ratio of the Rent(as % of GDP) in 1973 in Latin America(all income levels) to that in Latin America(developing only)?
Make the answer very short. 1.18. What is the difference between the highest and the second highest Rent(as % of GDP) in 1970?
Your response must be concise. 3.83. What is the difference between the highest and the second highest Rent(as % of GDP) of 1971?
Your answer should be very brief. 2.37. What is the difference between the highest and the second highest Rent(as % of GDP) of 1972?
Give a very brief answer. 2.25. What is the difference between the highest and the second highest Rent(as % of GDP) of 1973?
Make the answer very short. 3.93. What is the difference between the highest and the lowest Rent(as % of GDP) in 1970?
Offer a terse response. 4.64. What is the difference between the highest and the lowest Rent(as % of GDP) of 1971?
Your answer should be compact. 2.97. What is the difference between the highest and the lowest Rent(as % of GDP) in 1972?
Offer a terse response. 2.83. What is the difference between the highest and the lowest Rent(as % of GDP) of 1973?
Provide a short and direct response. 4.75. 